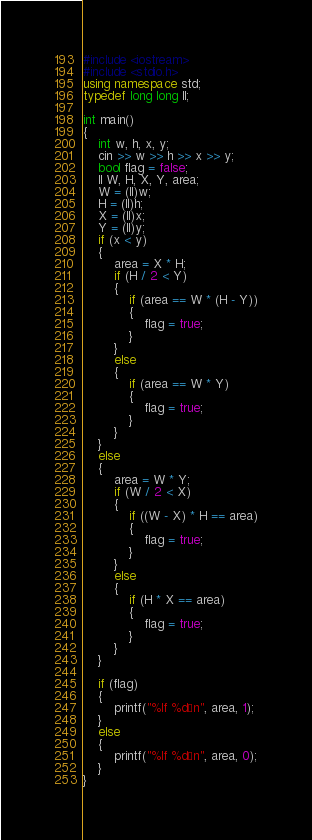<code> <loc_0><loc_0><loc_500><loc_500><_C++_>#include <iostream>
#include <stdio.h>
using namespace std;
typedef long long ll;

int main()
{
    int w, h, x, y;
    cin >> w >> h >> x >> y;
    bool flag = false;
    ll W, H, X, Y, area;
    W = (ll)w;
    H = (ll)h;
    X = (ll)x;
    Y = (ll)y;
    if (x < y)
    {
        area = X * H;
        if (H / 2 < Y)
        {
            if (area == W * (H - Y))
            {
                flag = true;
            }
        }
        else
        {
            if (area == W * Y)
            {
                flag = true;
            }
        }
    }
    else
    {
        area = W * Y;
        if (W / 2 < X)
        {
            if ((W - X) * H == area)
            {
                flag = true;
            }
        }
        else
        {
            if (H * X == area)
            {
                flag = true;
            }
        }
    }

    if (flag)
    {
        printf("%lf %d¥n", area, 1);
    }
    else
    {
        printf("%lf %d¥n", area, 0);
    }
}</code> 